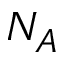<formula> <loc_0><loc_0><loc_500><loc_500>N _ { A }</formula> 